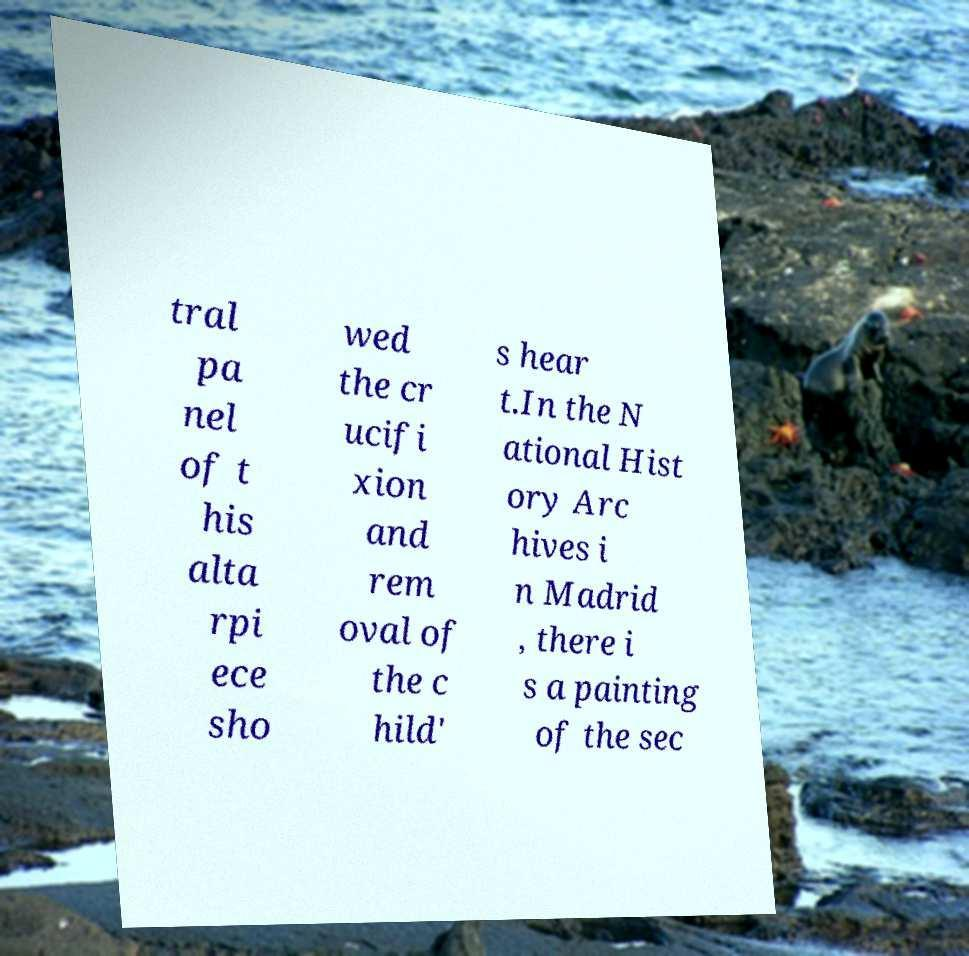Can you accurately transcribe the text from the provided image for me? tral pa nel of t his alta rpi ece sho wed the cr ucifi xion and rem oval of the c hild' s hear t.In the N ational Hist ory Arc hives i n Madrid , there i s a painting of the sec 